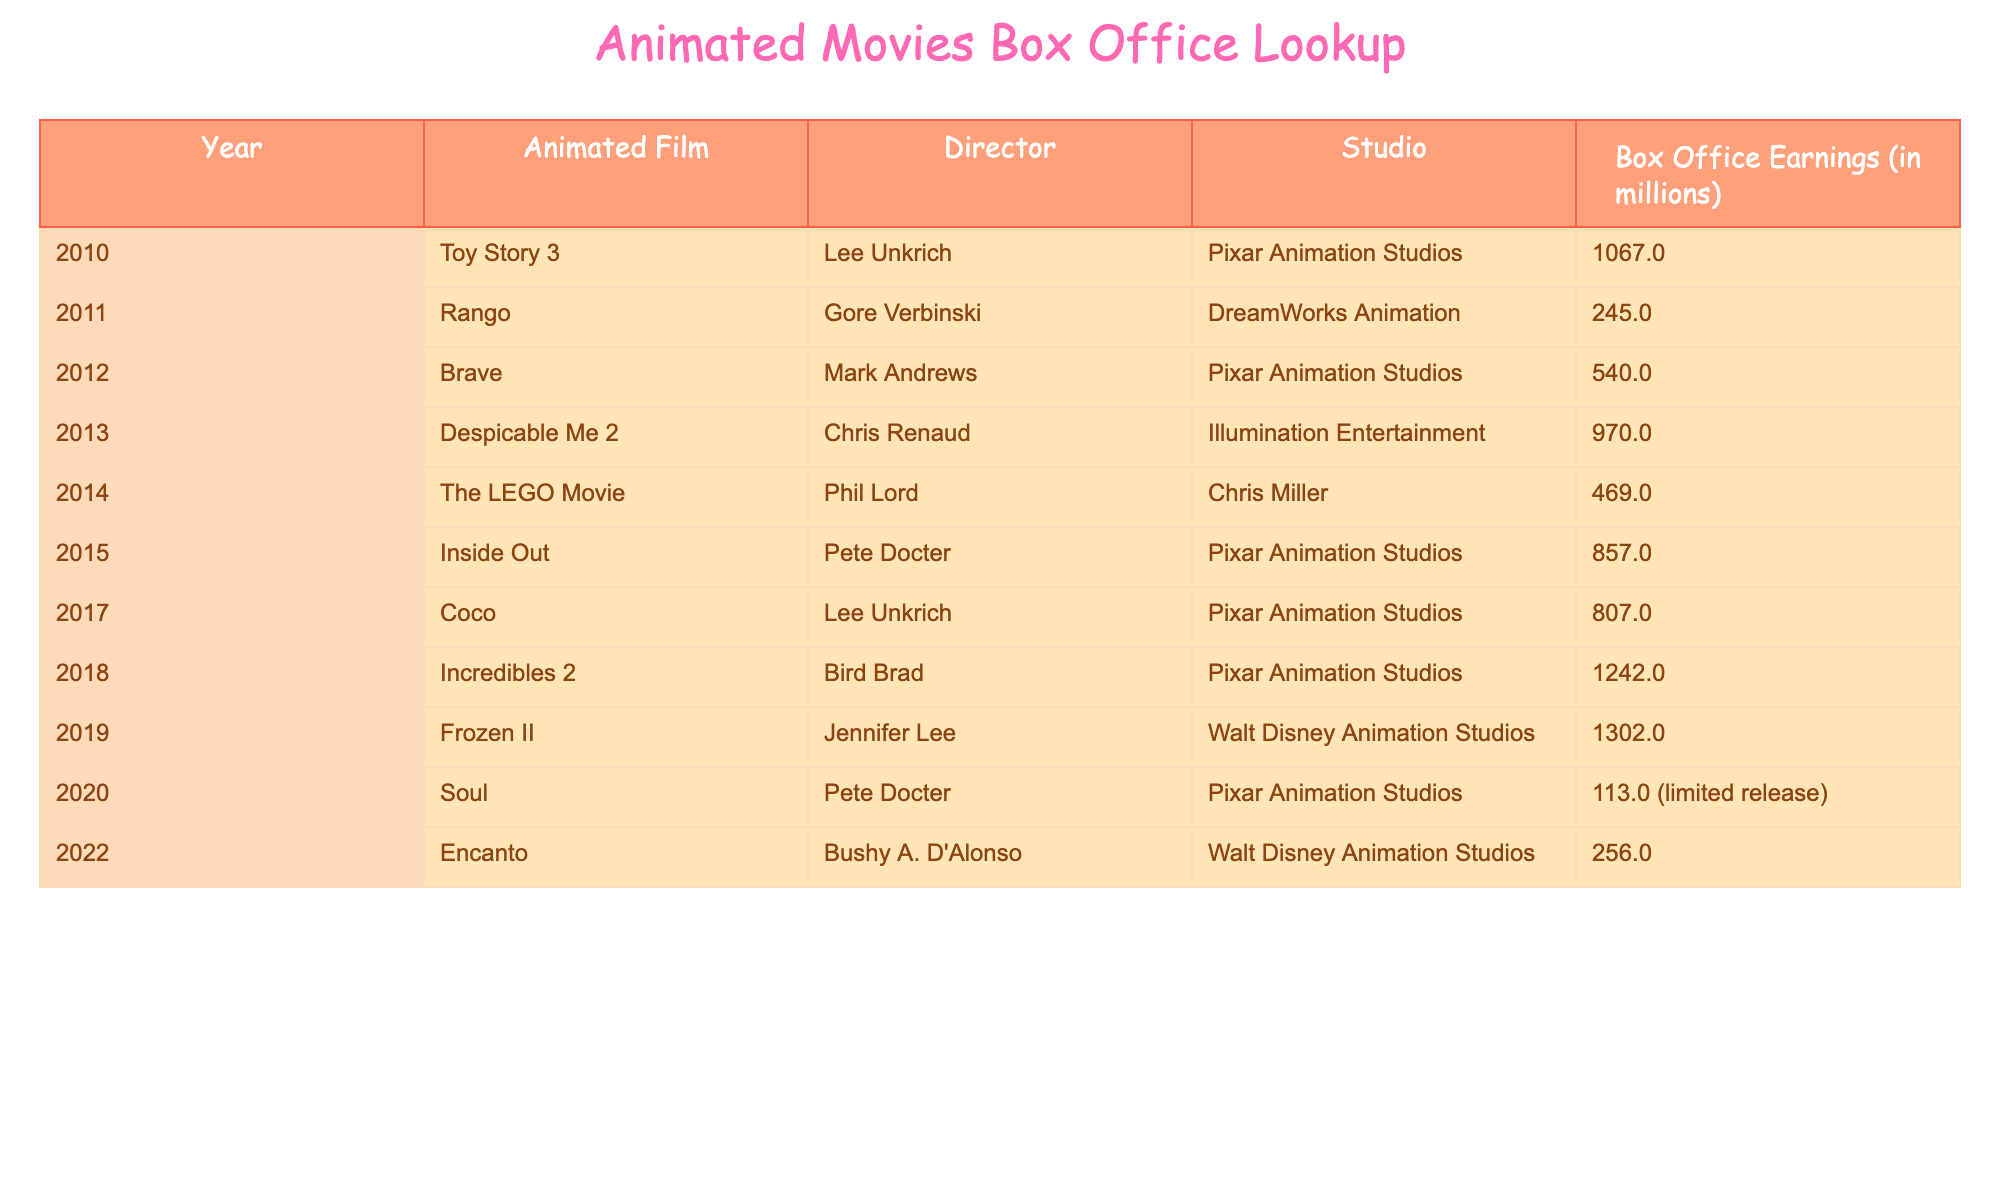What animated film had the highest box office earnings in 2019? The table shows that "Frozen II" was released in 2019, and its box office earnings were 1302.0 million. Therefore, it is the animated film with the highest earnings for that year.
Answer: Frozen II What was the total box office earnings of Pixar Animation Studios films listed in the table? The films from Pixar Animation Studios included "Toy Story 3" (1067.0), "Brave" (540.0), "Inside Out" (857.0), "Coco" (807.0), "Incredibles 2" (1242.0), and "Soul" (113.0). Adding these together gives: 1067.0 + 540.0 + 857.0 + 807.0 + 1242.0 + 113.0 = 3826.0 million.
Answer: 3826.0 million Did "The LEGO Movie" make more money than "Rango"? "The LEGO Movie" had box office earnings of 469.0 million, whereas "Rango" earned 245.0 million. Since 469.0 is greater than 245.0, "The LEGO Movie" did make more money than "Rango".
Answer: Yes What is the difference in box office earnings between "Incredibles 2" and "Coco"? "Incredibles 2" earned 1242.0 million and "Coco" earned 807.0 million. To find the difference, we subtract: 1242.0 - 807.0 = 435.0 million.
Answer: 435.0 million Which studio had the animated film with the lowest earnings in 2020? The only animated film listed for 2020 is "Soul," produced by Pixar Animation Studios, which earned 113.0 million. It is therefore the film with the lowest earnings in that year.
Answer: Pixar Animation Studios 